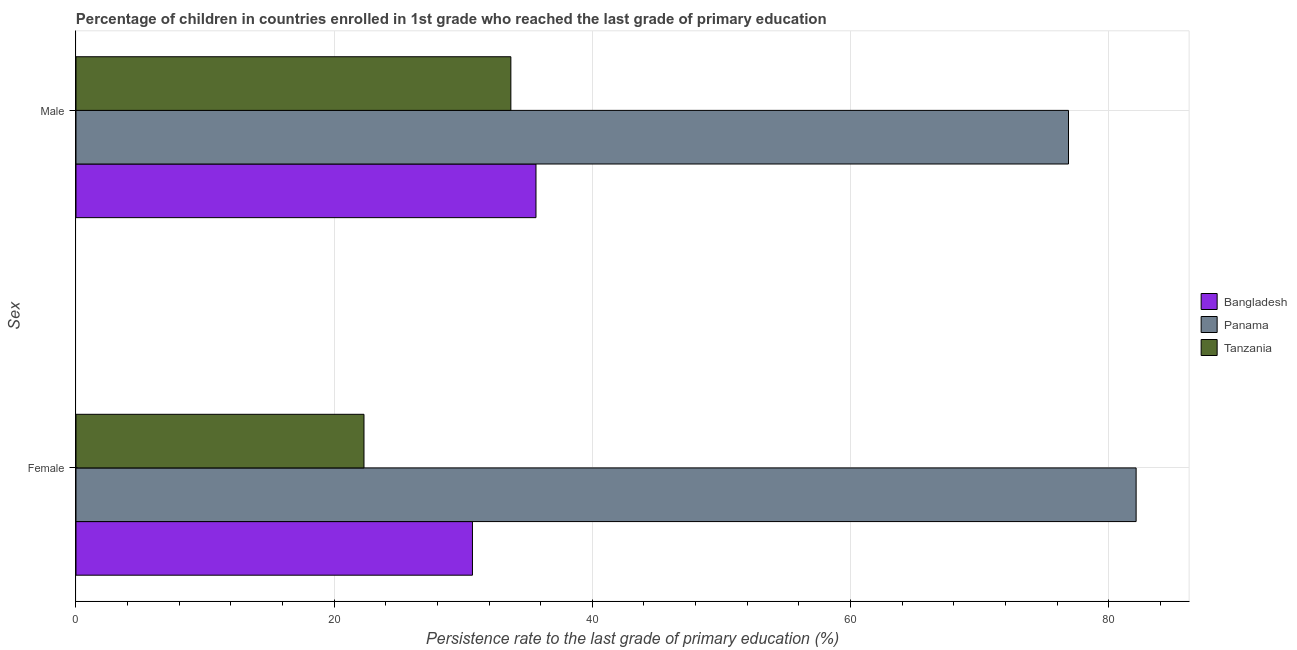How many bars are there on the 2nd tick from the bottom?
Offer a very short reply. 3. What is the label of the 2nd group of bars from the top?
Provide a succinct answer. Female. What is the persistence rate of female students in Bangladesh?
Your response must be concise. 30.71. Across all countries, what is the maximum persistence rate of male students?
Keep it short and to the point. 76.89. Across all countries, what is the minimum persistence rate of female students?
Give a very brief answer. 22.31. In which country was the persistence rate of female students maximum?
Keep it short and to the point. Panama. In which country was the persistence rate of female students minimum?
Your answer should be compact. Tanzania. What is the total persistence rate of male students in the graph?
Make the answer very short. 146.22. What is the difference between the persistence rate of female students in Bangladesh and that in Panama?
Your response must be concise. -51.42. What is the difference between the persistence rate of female students in Panama and the persistence rate of male students in Bangladesh?
Give a very brief answer. 46.49. What is the average persistence rate of female students per country?
Offer a very short reply. 45.05. What is the difference between the persistence rate of male students and persistence rate of female students in Panama?
Offer a terse response. -5.24. What is the ratio of the persistence rate of male students in Tanzania to that in Bangladesh?
Your answer should be very brief. 0.95. Is the persistence rate of male students in Panama less than that in Tanzania?
Your answer should be compact. No. What does the 2nd bar from the top in Male represents?
Offer a terse response. Panama. What does the 2nd bar from the bottom in Male represents?
Your response must be concise. Panama. How many bars are there?
Ensure brevity in your answer.  6. How many countries are there in the graph?
Keep it short and to the point. 3. Does the graph contain any zero values?
Offer a very short reply. No. Does the graph contain grids?
Provide a succinct answer. Yes. How many legend labels are there?
Offer a terse response. 3. How are the legend labels stacked?
Ensure brevity in your answer.  Vertical. What is the title of the graph?
Provide a short and direct response. Percentage of children in countries enrolled in 1st grade who reached the last grade of primary education. Does "St. Lucia" appear as one of the legend labels in the graph?
Your answer should be very brief. No. What is the label or title of the X-axis?
Make the answer very short. Persistence rate to the last grade of primary education (%). What is the label or title of the Y-axis?
Make the answer very short. Sex. What is the Persistence rate to the last grade of primary education (%) of Bangladesh in Female?
Make the answer very short. 30.71. What is the Persistence rate to the last grade of primary education (%) of Panama in Female?
Keep it short and to the point. 82.13. What is the Persistence rate to the last grade of primary education (%) in Tanzania in Female?
Provide a short and direct response. 22.31. What is the Persistence rate to the last grade of primary education (%) of Bangladesh in Male?
Provide a succinct answer. 35.64. What is the Persistence rate to the last grade of primary education (%) in Panama in Male?
Ensure brevity in your answer.  76.89. What is the Persistence rate to the last grade of primary education (%) in Tanzania in Male?
Your answer should be very brief. 33.69. Across all Sex, what is the maximum Persistence rate to the last grade of primary education (%) in Bangladesh?
Provide a short and direct response. 35.64. Across all Sex, what is the maximum Persistence rate to the last grade of primary education (%) in Panama?
Ensure brevity in your answer.  82.13. Across all Sex, what is the maximum Persistence rate to the last grade of primary education (%) of Tanzania?
Keep it short and to the point. 33.69. Across all Sex, what is the minimum Persistence rate to the last grade of primary education (%) in Bangladesh?
Your answer should be compact. 30.71. Across all Sex, what is the minimum Persistence rate to the last grade of primary education (%) of Panama?
Ensure brevity in your answer.  76.89. Across all Sex, what is the minimum Persistence rate to the last grade of primary education (%) in Tanzania?
Your response must be concise. 22.31. What is the total Persistence rate to the last grade of primary education (%) of Bangladesh in the graph?
Your answer should be compact. 66.35. What is the total Persistence rate to the last grade of primary education (%) in Panama in the graph?
Offer a terse response. 159.02. What is the total Persistence rate to the last grade of primary education (%) of Tanzania in the graph?
Offer a terse response. 56. What is the difference between the Persistence rate to the last grade of primary education (%) in Bangladesh in Female and that in Male?
Offer a very short reply. -4.92. What is the difference between the Persistence rate to the last grade of primary education (%) in Panama in Female and that in Male?
Keep it short and to the point. 5.24. What is the difference between the Persistence rate to the last grade of primary education (%) of Tanzania in Female and that in Male?
Offer a very short reply. -11.38. What is the difference between the Persistence rate to the last grade of primary education (%) of Bangladesh in Female and the Persistence rate to the last grade of primary education (%) of Panama in Male?
Your answer should be compact. -46.18. What is the difference between the Persistence rate to the last grade of primary education (%) of Bangladesh in Female and the Persistence rate to the last grade of primary education (%) of Tanzania in Male?
Keep it short and to the point. -2.98. What is the difference between the Persistence rate to the last grade of primary education (%) of Panama in Female and the Persistence rate to the last grade of primary education (%) of Tanzania in Male?
Keep it short and to the point. 48.44. What is the average Persistence rate to the last grade of primary education (%) of Bangladesh per Sex?
Offer a very short reply. 33.18. What is the average Persistence rate to the last grade of primary education (%) of Panama per Sex?
Your response must be concise. 79.51. What is the average Persistence rate to the last grade of primary education (%) in Tanzania per Sex?
Give a very brief answer. 28. What is the difference between the Persistence rate to the last grade of primary education (%) of Bangladesh and Persistence rate to the last grade of primary education (%) of Panama in Female?
Your answer should be very brief. -51.42. What is the difference between the Persistence rate to the last grade of primary education (%) in Bangladesh and Persistence rate to the last grade of primary education (%) in Tanzania in Female?
Ensure brevity in your answer.  8.4. What is the difference between the Persistence rate to the last grade of primary education (%) in Panama and Persistence rate to the last grade of primary education (%) in Tanzania in Female?
Make the answer very short. 59.82. What is the difference between the Persistence rate to the last grade of primary education (%) of Bangladesh and Persistence rate to the last grade of primary education (%) of Panama in Male?
Ensure brevity in your answer.  -41.25. What is the difference between the Persistence rate to the last grade of primary education (%) of Bangladesh and Persistence rate to the last grade of primary education (%) of Tanzania in Male?
Ensure brevity in your answer.  1.95. What is the difference between the Persistence rate to the last grade of primary education (%) of Panama and Persistence rate to the last grade of primary education (%) of Tanzania in Male?
Ensure brevity in your answer.  43.2. What is the ratio of the Persistence rate to the last grade of primary education (%) in Bangladesh in Female to that in Male?
Ensure brevity in your answer.  0.86. What is the ratio of the Persistence rate to the last grade of primary education (%) of Panama in Female to that in Male?
Offer a very short reply. 1.07. What is the ratio of the Persistence rate to the last grade of primary education (%) of Tanzania in Female to that in Male?
Your answer should be compact. 0.66. What is the difference between the highest and the second highest Persistence rate to the last grade of primary education (%) in Bangladesh?
Offer a very short reply. 4.92. What is the difference between the highest and the second highest Persistence rate to the last grade of primary education (%) in Panama?
Your answer should be compact. 5.24. What is the difference between the highest and the second highest Persistence rate to the last grade of primary education (%) of Tanzania?
Your response must be concise. 11.38. What is the difference between the highest and the lowest Persistence rate to the last grade of primary education (%) in Bangladesh?
Provide a short and direct response. 4.92. What is the difference between the highest and the lowest Persistence rate to the last grade of primary education (%) in Panama?
Make the answer very short. 5.24. What is the difference between the highest and the lowest Persistence rate to the last grade of primary education (%) in Tanzania?
Offer a very short reply. 11.38. 